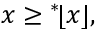Convert formula to latex. <formula><loc_0><loc_0><loc_500><loc_500>x ^ { * } \, \lfloor x \rfloor ,</formula> 